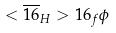Convert formula to latex. <formula><loc_0><loc_0><loc_500><loc_500>< \overline { 1 6 } _ { H } > 1 6 _ { f } \phi</formula> 